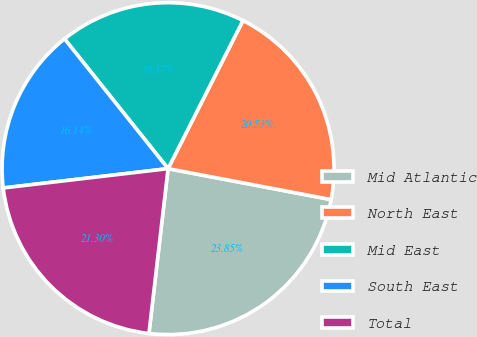<chart> <loc_0><loc_0><loc_500><loc_500><pie_chart><fcel>Mid Atlantic<fcel>North East<fcel>Mid East<fcel>South East<fcel>Total<nl><fcel>23.85%<fcel>20.53%<fcel>18.17%<fcel>16.14%<fcel>21.3%<nl></chart> 